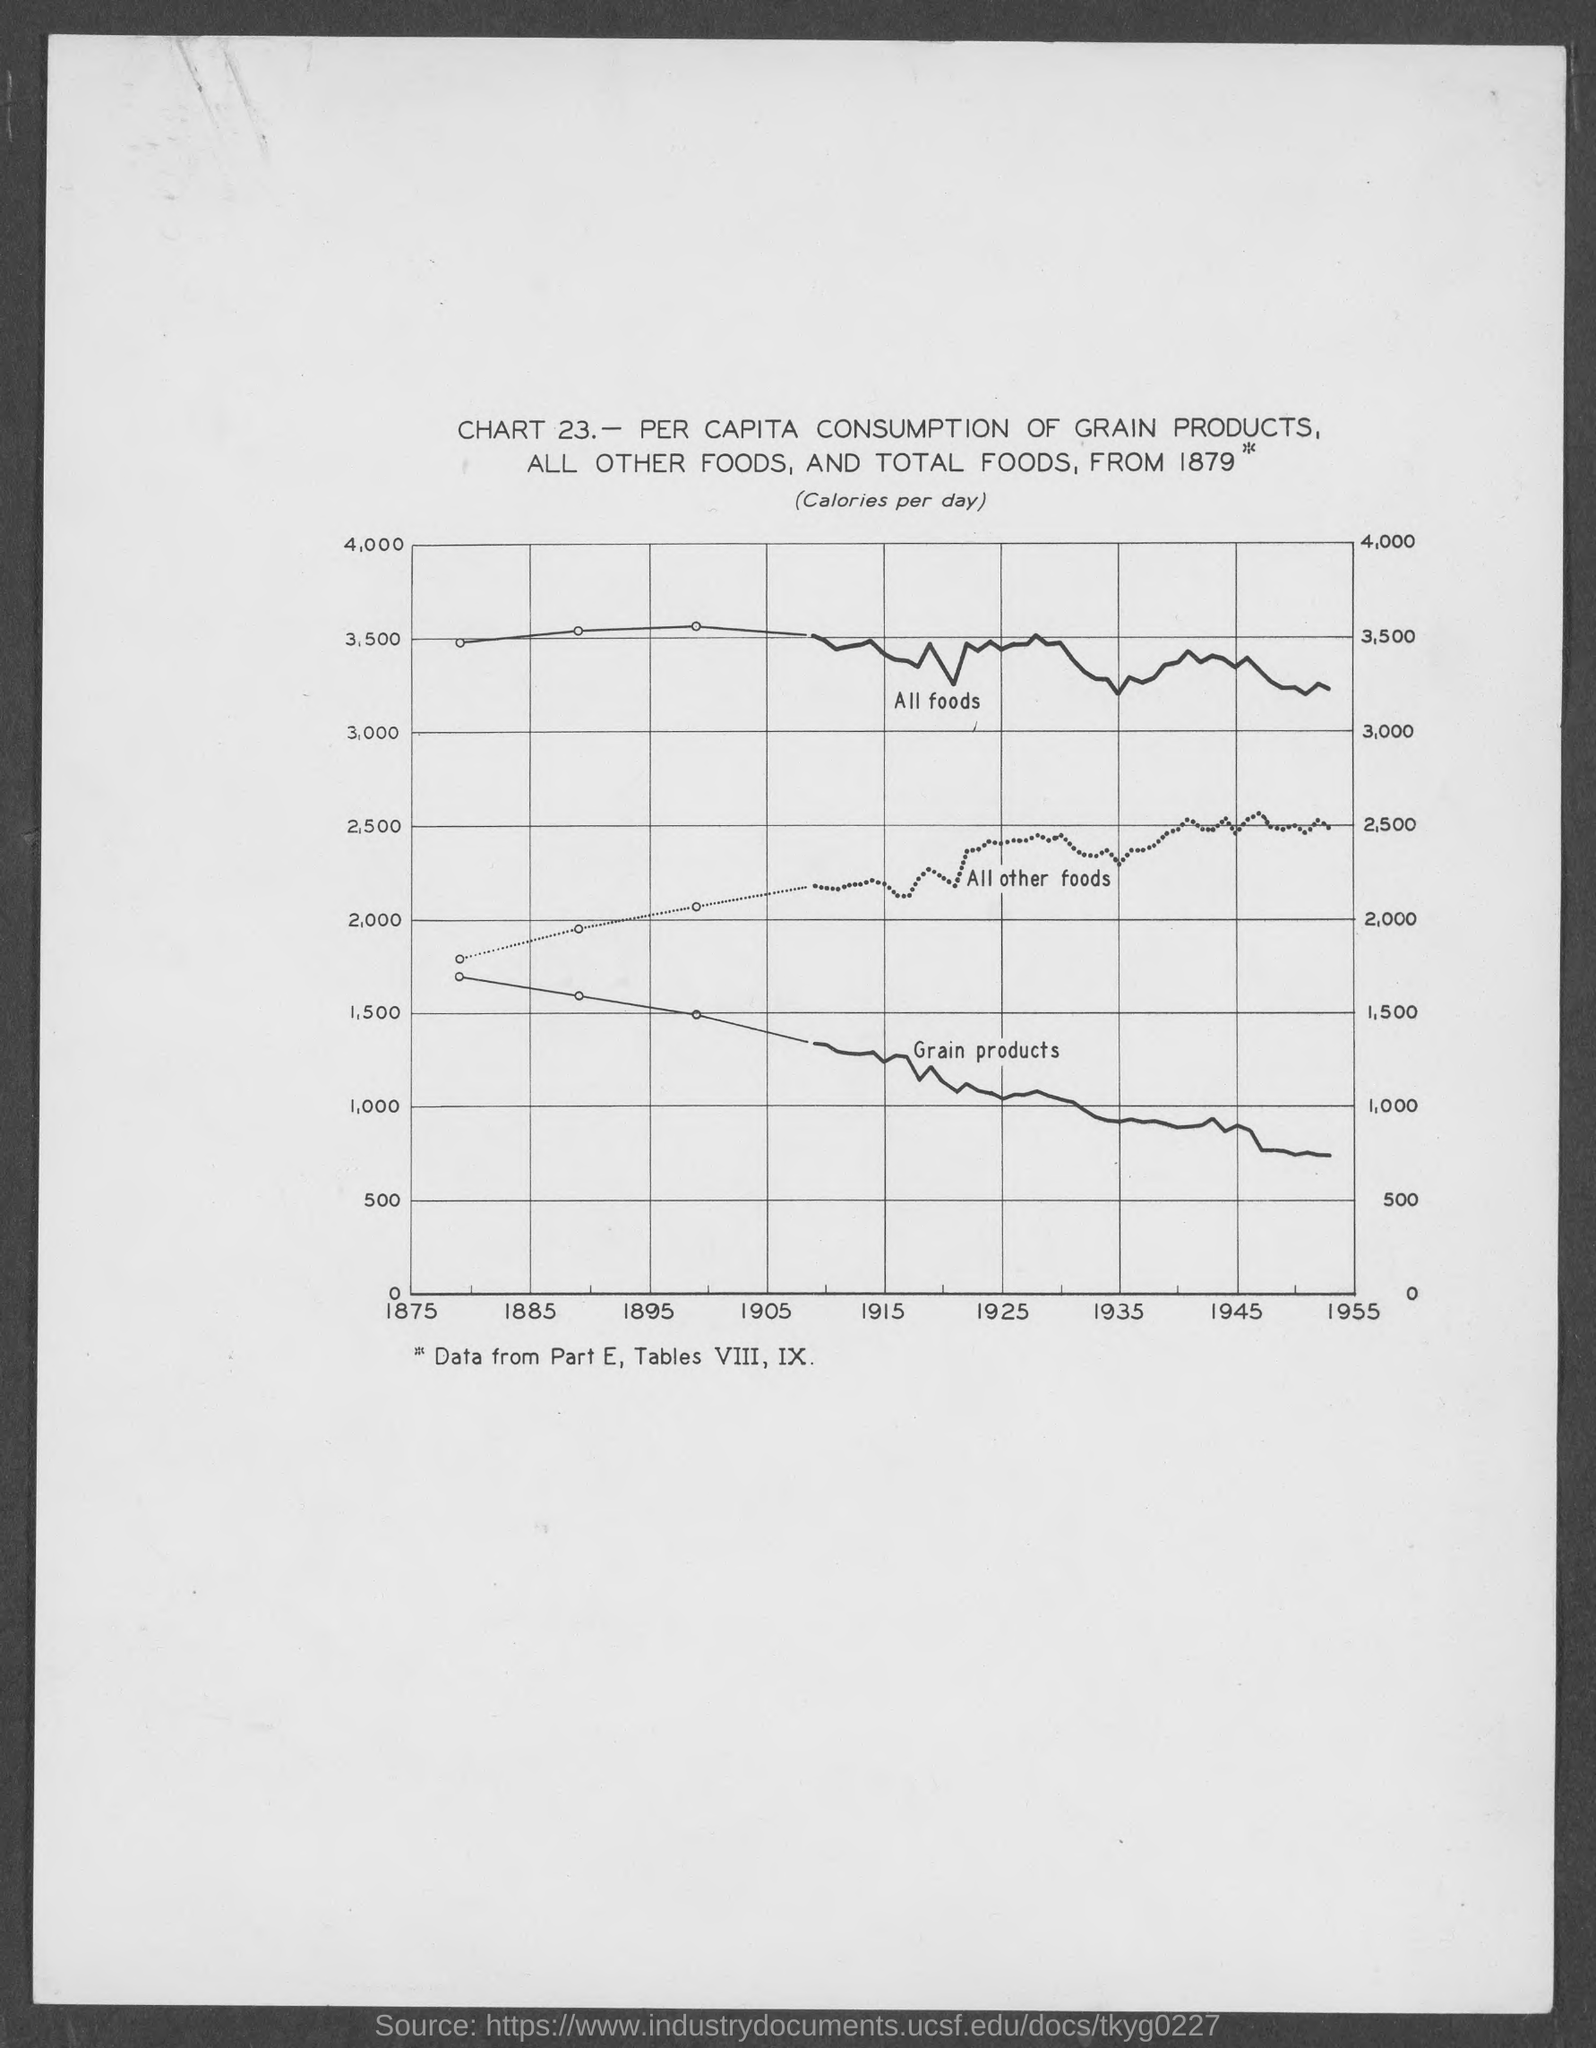What is the maximum value on the Y axis?
Offer a very short reply. 4,000. What is the first value on the X axis?
Give a very brief answer. 1875. What is written within parentheses, just below the title?
Provide a succinct answer. CALORIES PER DAY. What is the label for the topmost curve?
Your response must be concise. All foods. 